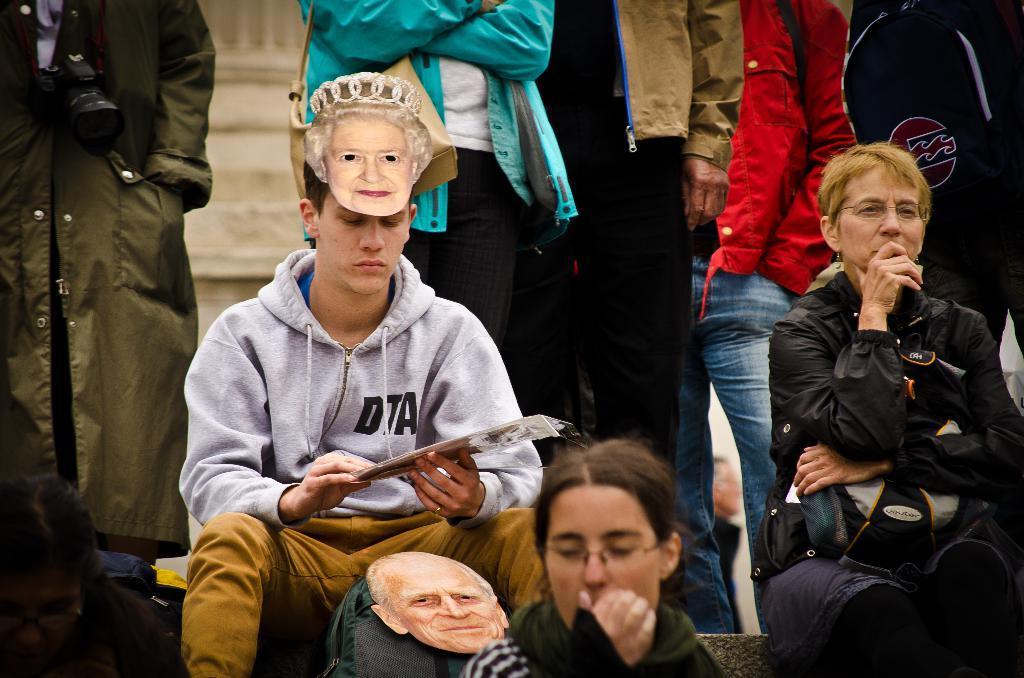Can you describe this image briefly? In the foreground of this image, on the bottom, there are two women. In the middle, there is a woman holding bag and a man sitting and wearing a woman´s face mask on his head and also holding a booklet like an object and there is a bag in front of him on which a mens face mask is present on it. In the background, there are persons standing and the wall of a building. 